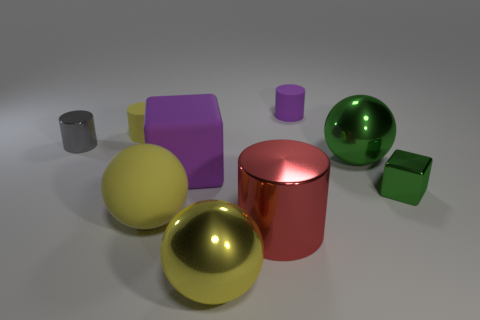There is a purple matte object left of the small cylinder that is behind the yellow matte object that is behind the large green sphere; what is its size?
Provide a short and direct response. Large. How many things are cylinders that are on the right side of the gray shiny thing or small blocks?
Give a very brief answer. 4. What number of big purple rubber cubes are behind the small rubber cylinder on the left side of the big red thing?
Offer a terse response. 0. Are there more rubber objects that are behind the purple cylinder than yellow metal cylinders?
Provide a succinct answer. No. There is a shiny thing that is both behind the small cube and to the right of the tiny purple rubber cylinder; what is its size?
Your answer should be very brief. Large. What shape is the metallic thing that is both on the left side of the big red metal cylinder and in front of the big matte ball?
Ensure brevity in your answer.  Sphere. There is a yellow thing that is behind the large sphere left of the big purple object; are there any big cylinders that are on the left side of it?
Your response must be concise. No. How many objects are either cylinders that are on the right side of the tiny gray shiny object or matte objects to the left of the red cylinder?
Provide a succinct answer. 5. Does the big ball that is right of the yellow metal object have the same material as the tiny gray cylinder?
Keep it short and to the point. Yes. There is a big ball that is both to the right of the yellow rubber sphere and in front of the green metal block; what material is it?
Your answer should be compact. Metal. 